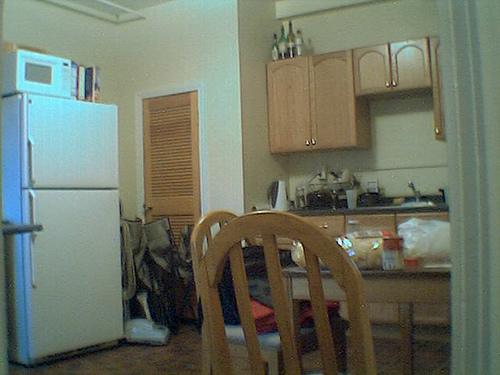Where is the refrigerator?
Answer briefly. Left. How many red chairs are there?
Give a very brief answer. 0. How many chairs are here?
Answer briefly. 2. Does the refrigerator have an ice maker?
Write a very short answer. No. Aside from white, what is the other dominant color of the bathroom interior?
Be succinct. Brown. What could be moved to clear passageway?
Keep it brief. Chair. Do both of the chairs at the table match?
Write a very short answer. Yes. Is the kitchen clean?
Be succinct. No. Where is the microwave?
Keep it brief. Top of fridge. What color are the cabinets in this image?
Be succinct. Brown. What kind of furniture is in the front of the picture?
Be succinct. Chair. What type of soda is in the fridge?
Quick response, please. Coke. What is on top of the cabinet?
Short answer required. Bottles. 